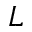Convert formula to latex. <formula><loc_0><loc_0><loc_500><loc_500>L</formula> 